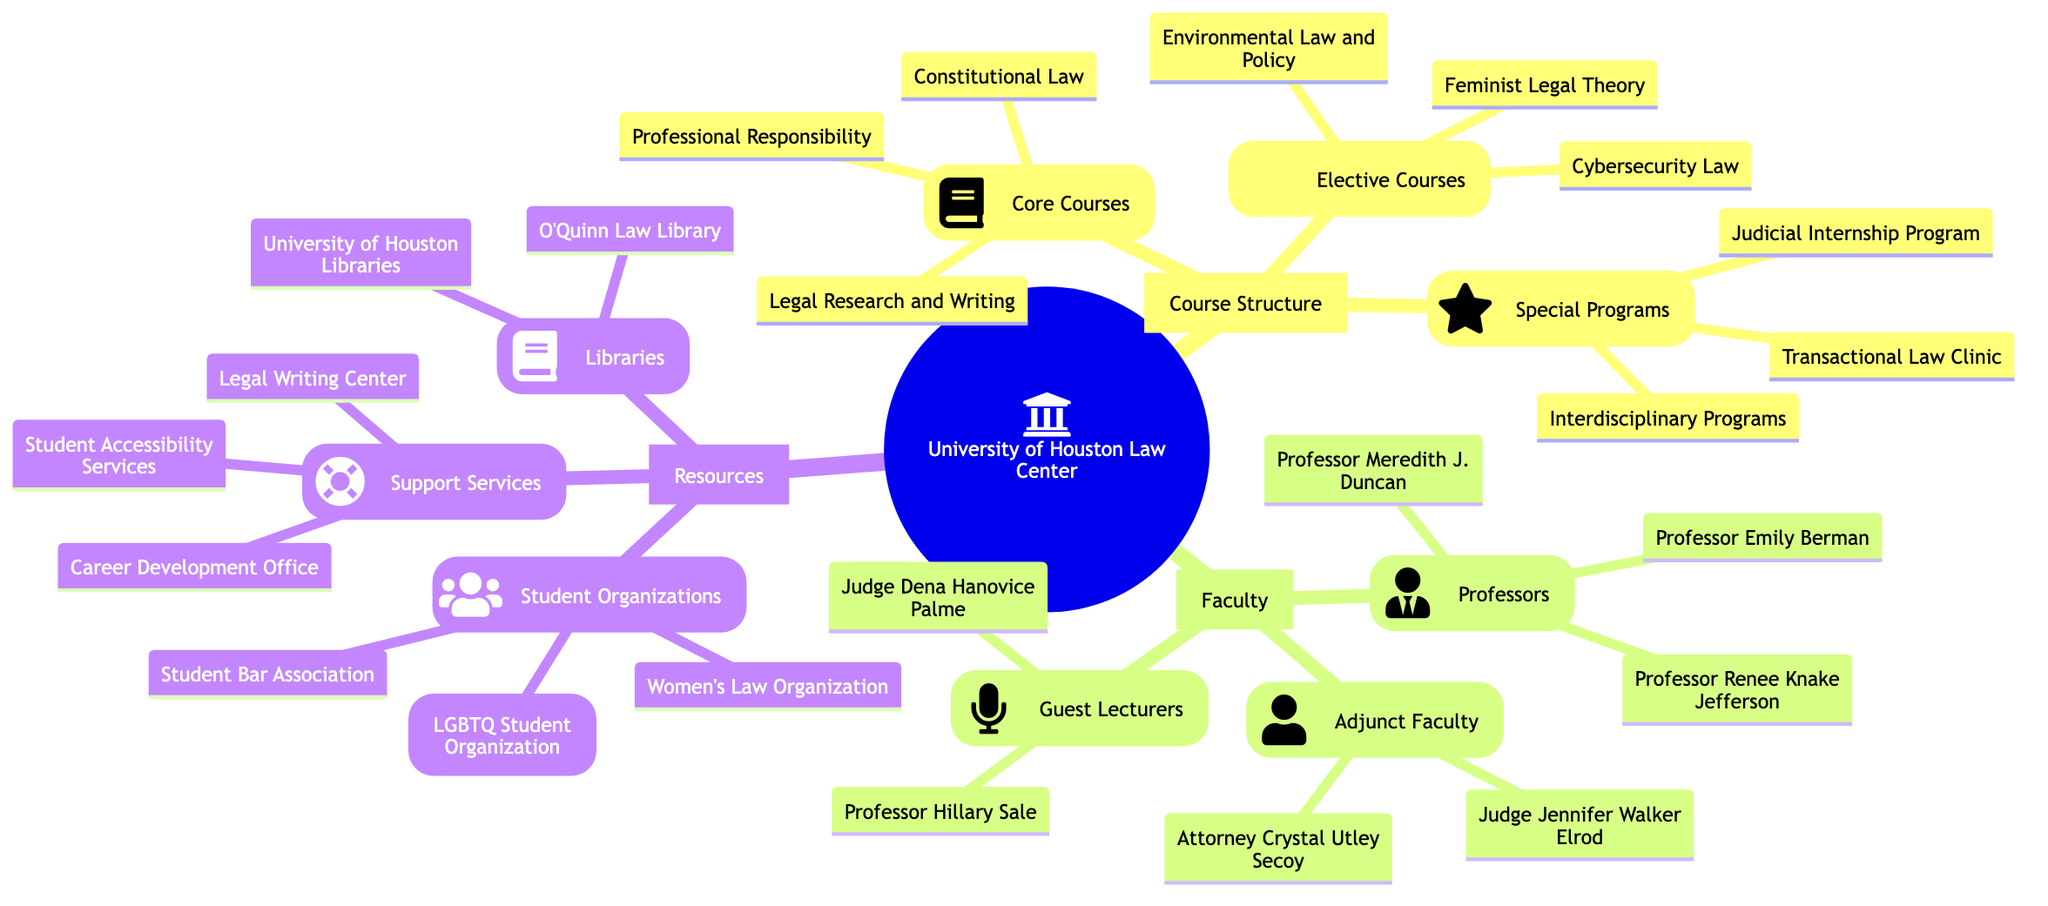What are the core courses offered at the University of Houston Law Center? According to the diagram, the core courses listed under the Course Structure section include Professional Responsibility, Legal Research and Writing, and Constitutional Law.
Answer: Professional Responsibility, Legal Research and Writing, Constitutional Law How many professors are listed in the Faculty section? The diagram outlines three categories under Faculty: Professors, Adjunct Faculty, and Guest Lecturers. In the Professors category, there are three professors mentioned: Professor Renee Knake Jefferson, Professor Meredith J. Duncan, and Professor Emily Berman.
Answer: 3 Which elective course focuses on gender issues? Within the elective courses listed, Feminist Legal Theory specifically addresses gender issues. The other electives, Cybersecurity Law and Environmental Law and Policy, focus on different areas of law.
Answer: Feminist Legal Theory What is one of the support services available to students? The Support Services category highlights three services: Legal Writing Center, Career Development Office, and Student Accessibility Services. Any one of these services can answer the question. For instance, the Legal Writing Center is one of the services that assist students.
Answer: Legal Writing Center How many student organizations are mentioned in the Resources section? In the diagram, under the Resources section, there are three student organizations listed: Women's Law Organization, Outlaw (LGBTQ Student Organization), and Student Bar Association. By counting these, we find there are three organizations mentioned in total.
Answer: 3 Which special program allows for real-world legal experience? The Judicial Internship Program is the special program listed that provides students with real-world legal experience while they study. This program is one of the special programs under the Course Structure category.
Answer: Judicial Internship Program Which type of faculty member is Judge Jennifer Walker Elrod? Judge Jennifer Walker Elrod is listed under the Adjunct Faculty category in the Faculty section of the diagram. Adjunct faculty members are generally part-time instructors who bring practical experience alongside their teaching roles.
Answer: Adjunct Faculty What library is specifically named for law resources? The diagram names O'Quinn Law Library in the Libraries category under Resources as a dedicated facility for law resources, distinguishing it from University of Houston Libraries, which serves a broader range of subjects.
Answer: O'Quinn Law Library How does the number of core courses compare to elective courses? There are three core courses (Professional Responsibility, Legal Research and Writing, Constitutional Law) and three elective courses (Feminist Legal Theory, Cybersecurity Law, Environmental Law and Policy). Therefore, the number of core courses is equal to the number of elective courses, as both categories list three courses each.
Answer: Equal 